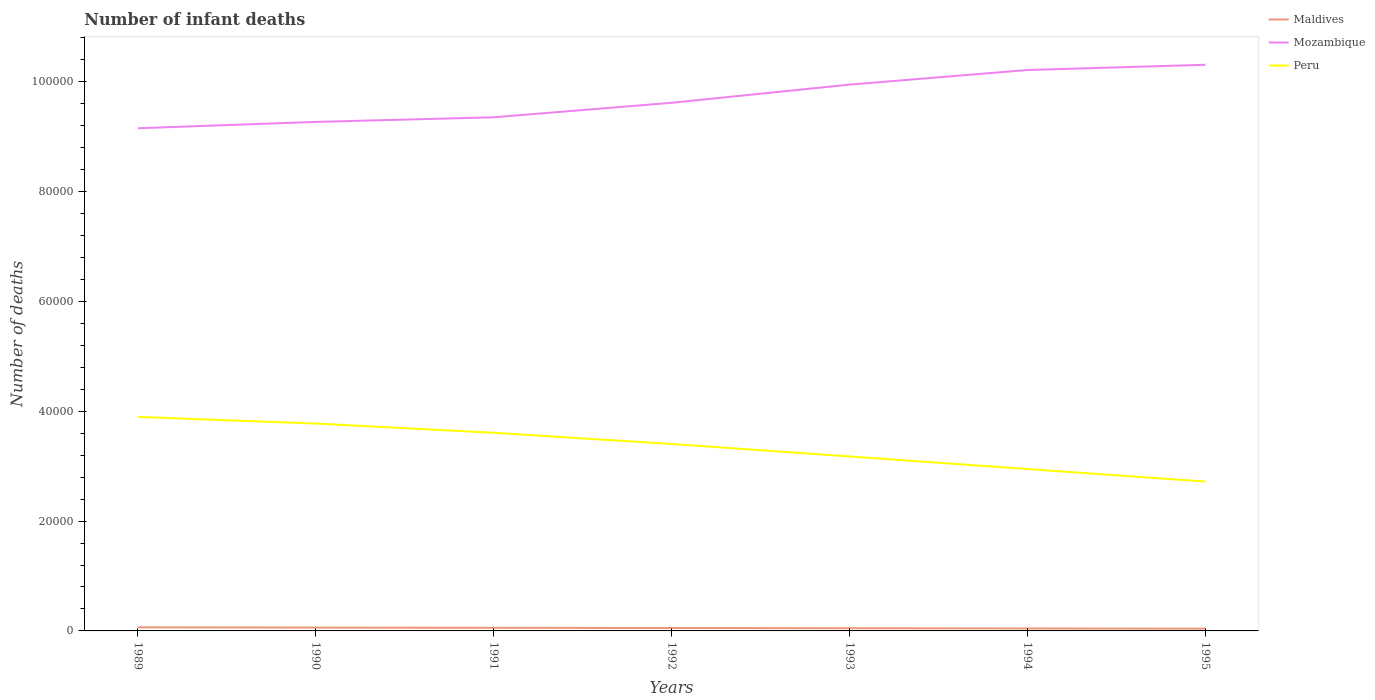Does the line corresponding to Mozambique intersect with the line corresponding to Peru?
Provide a short and direct response. No. Is the number of lines equal to the number of legend labels?
Offer a terse response. Yes. Across all years, what is the maximum number of infant deaths in Maldives?
Keep it short and to the point. 410. In which year was the number of infant deaths in Maldives maximum?
Keep it short and to the point. 1995. What is the total number of infant deaths in Mozambique in the graph?
Your answer should be compact. -3313. What is the difference between the highest and the second highest number of infant deaths in Peru?
Keep it short and to the point. 1.18e+04. What is the difference between the highest and the lowest number of infant deaths in Maldives?
Your answer should be compact. 4. Is the number of infant deaths in Mozambique strictly greater than the number of infant deaths in Peru over the years?
Your answer should be compact. No. How many years are there in the graph?
Provide a succinct answer. 7. Are the values on the major ticks of Y-axis written in scientific E-notation?
Your answer should be compact. No. What is the title of the graph?
Your answer should be very brief. Number of infant deaths. Does "Switzerland" appear as one of the legend labels in the graph?
Provide a short and direct response. No. What is the label or title of the X-axis?
Ensure brevity in your answer.  Years. What is the label or title of the Y-axis?
Offer a terse response. Number of deaths. What is the Number of deaths in Maldives in 1989?
Give a very brief answer. 653. What is the Number of deaths of Mozambique in 1989?
Give a very brief answer. 9.15e+04. What is the Number of deaths in Peru in 1989?
Offer a very short reply. 3.90e+04. What is the Number of deaths of Maldives in 1990?
Offer a terse response. 610. What is the Number of deaths in Mozambique in 1990?
Provide a succinct answer. 9.27e+04. What is the Number of deaths of Peru in 1990?
Provide a succinct answer. 3.78e+04. What is the Number of deaths in Maldives in 1991?
Keep it short and to the point. 570. What is the Number of deaths in Mozambique in 1991?
Your answer should be very brief. 9.35e+04. What is the Number of deaths in Peru in 1991?
Provide a succinct answer. 3.61e+04. What is the Number of deaths of Maldives in 1992?
Give a very brief answer. 531. What is the Number of deaths of Mozambique in 1992?
Make the answer very short. 9.62e+04. What is the Number of deaths in Peru in 1992?
Make the answer very short. 3.40e+04. What is the Number of deaths in Maldives in 1993?
Give a very brief answer. 491. What is the Number of deaths in Mozambique in 1993?
Your response must be concise. 9.95e+04. What is the Number of deaths of Peru in 1993?
Ensure brevity in your answer.  3.18e+04. What is the Number of deaths in Maldives in 1994?
Offer a very short reply. 450. What is the Number of deaths of Mozambique in 1994?
Make the answer very short. 1.02e+05. What is the Number of deaths in Peru in 1994?
Give a very brief answer. 2.95e+04. What is the Number of deaths in Maldives in 1995?
Give a very brief answer. 410. What is the Number of deaths in Mozambique in 1995?
Offer a terse response. 1.03e+05. What is the Number of deaths in Peru in 1995?
Keep it short and to the point. 2.72e+04. Across all years, what is the maximum Number of deaths of Maldives?
Your answer should be compact. 653. Across all years, what is the maximum Number of deaths in Mozambique?
Your answer should be very brief. 1.03e+05. Across all years, what is the maximum Number of deaths of Peru?
Provide a succinct answer. 3.90e+04. Across all years, what is the minimum Number of deaths of Maldives?
Provide a short and direct response. 410. Across all years, what is the minimum Number of deaths in Mozambique?
Offer a very short reply. 9.15e+04. Across all years, what is the minimum Number of deaths of Peru?
Your answer should be very brief. 2.72e+04. What is the total Number of deaths in Maldives in the graph?
Keep it short and to the point. 3715. What is the total Number of deaths in Mozambique in the graph?
Your response must be concise. 6.79e+05. What is the total Number of deaths in Peru in the graph?
Provide a short and direct response. 2.35e+05. What is the difference between the Number of deaths of Maldives in 1989 and that in 1990?
Offer a very short reply. 43. What is the difference between the Number of deaths of Mozambique in 1989 and that in 1990?
Give a very brief answer. -1155. What is the difference between the Number of deaths in Peru in 1989 and that in 1990?
Your answer should be very brief. 1211. What is the difference between the Number of deaths in Maldives in 1989 and that in 1991?
Offer a very short reply. 83. What is the difference between the Number of deaths of Mozambique in 1989 and that in 1991?
Keep it short and to the point. -1999. What is the difference between the Number of deaths of Peru in 1989 and that in 1991?
Keep it short and to the point. 2893. What is the difference between the Number of deaths in Maldives in 1989 and that in 1992?
Your answer should be compact. 122. What is the difference between the Number of deaths in Mozambique in 1989 and that in 1992?
Provide a short and direct response. -4634. What is the difference between the Number of deaths of Peru in 1989 and that in 1992?
Offer a terse response. 4930. What is the difference between the Number of deaths in Maldives in 1989 and that in 1993?
Provide a succinct answer. 162. What is the difference between the Number of deaths in Mozambique in 1989 and that in 1993?
Provide a short and direct response. -7947. What is the difference between the Number of deaths of Peru in 1989 and that in 1993?
Provide a succinct answer. 7202. What is the difference between the Number of deaths of Maldives in 1989 and that in 1994?
Your answer should be compact. 203. What is the difference between the Number of deaths of Mozambique in 1989 and that in 1994?
Ensure brevity in your answer.  -1.06e+04. What is the difference between the Number of deaths in Peru in 1989 and that in 1994?
Give a very brief answer. 9493. What is the difference between the Number of deaths of Maldives in 1989 and that in 1995?
Offer a very short reply. 243. What is the difference between the Number of deaths of Mozambique in 1989 and that in 1995?
Give a very brief answer. -1.16e+04. What is the difference between the Number of deaths of Peru in 1989 and that in 1995?
Give a very brief answer. 1.18e+04. What is the difference between the Number of deaths of Mozambique in 1990 and that in 1991?
Offer a very short reply. -844. What is the difference between the Number of deaths of Peru in 1990 and that in 1991?
Your answer should be compact. 1682. What is the difference between the Number of deaths of Maldives in 1990 and that in 1992?
Keep it short and to the point. 79. What is the difference between the Number of deaths of Mozambique in 1990 and that in 1992?
Provide a succinct answer. -3479. What is the difference between the Number of deaths in Peru in 1990 and that in 1992?
Offer a very short reply. 3719. What is the difference between the Number of deaths in Maldives in 1990 and that in 1993?
Provide a short and direct response. 119. What is the difference between the Number of deaths in Mozambique in 1990 and that in 1993?
Offer a terse response. -6792. What is the difference between the Number of deaths in Peru in 1990 and that in 1993?
Give a very brief answer. 5991. What is the difference between the Number of deaths in Maldives in 1990 and that in 1994?
Keep it short and to the point. 160. What is the difference between the Number of deaths in Mozambique in 1990 and that in 1994?
Ensure brevity in your answer.  -9450. What is the difference between the Number of deaths of Peru in 1990 and that in 1994?
Make the answer very short. 8282. What is the difference between the Number of deaths in Maldives in 1990 and that in 1995?
Offer a terse response. 200. What is the difference between the Number of deaths in Mozambique in 1990 and that in 1995?
Give a very brief answer. -1.04e+04. What is the difference between the Number of deaths of Peru in 1990 and that in 1995?
Offer a terse response. 1.06e+04. What is the difference between the Number of deaths in Maldives in 1991 and that in 1992?
Your answer should be compact. 39. What is the difference between the Number of deaths in Mozambique in 1991 and that in 1992?
Make the answer very short. -2635. What is the difference between the Number of deaths of Peru in 1991 and that in 1992?
Give a very brief answer. 2037. What is the difference between the Number of deaths of Maldives in 1991 and that in 1993?
Your answer should be compact. 79. What is the difference between the Number of deaths of Mozambique in 1991 and that in 1993?
Your answer should be compact. -5948. What is the difference between the Number of deaths of Peru in 1991 and that in 1993?
Your response must be concise. 4309. What is the difference between the Number of deaths of Maldives in 1991 and that in 1994?
Your answer should be very brief. 120. What is the difference between the Number of deaths of Mozambique in 1991 and that in 1994?
Make the answer very short. -8606. What is the difference between the Number of deaths in Peru in 1991 and that in 1994?
Provide a short and direct response. 6600. What is the difference between the Number of deaths of Maldives in 1991 and that in 1995?
Provide a short and direct response. 160. What is the difference between the Number of deaths in Mozambique in 1991 and that in 1995?
Give a very brief answer. -9562. What is the difference between the Number of deaths of Peru in 1991 and that in 1995?
Give a very brief answer. 8880. What is the difference between the Number of deaths in Maldives in 1992 and that in 1993?
Your answer should be compact. 40. What is the difference between the Number of deaths of Mozambique in 1992 and that in 1993?
Give a very brief answer. -3313. What is the difference between the Number of deaths in Peru in 1992 and that in 1993?
Provide a succinct answer. 2272. What is the difference between the Number of deaths in Mozambique in 1992 and that in 1994?
Provide a succinct answer. -5971. What is the difference between the Number of deaths in Peru in 1992 and that in 1994?
Provide a short and direct response. 4563. What is the difference between the Number of deaths of Maldives in 1992 and that in 1995?
Your answer should be very brief. 121. What is the difference between the Number of deaths of Mozambique in 1992 and that in 1995?
Offer a terse response. -6927. What is the difference between the Number of deaths in Peru in 1992 and that in 1995?
Provide a short and direct response. 6843. What is the difference between the Number of deaths of Maldives in 1993 and that in 1994?
Provide a short and direct response. 41. What is the difference between the Number of deaths of Mozambique in 1993 and that in 1994?
Make the answer very short. -2658. What is the difference between the Number of deaths in Peru in 1993 and that in 1994?
Give a very brief answer. 2291. What is the difference between the Number of deaths of Maldives in 1993 and that in 1995?
Keep it short and to the point. 81. What is the difference between the Number of deaths of Mozambique in 1993 and that in 1995?
Ensure brevity in your answer.  -3614. What is the difference between the Number of deaths of Peru in 1993 and that in 1995?
Provide a succinct answer. 4571. What is the difference between the Number of deaths in Maldives in 1994 and that in 1995?
Offer a very short reply. 40. What is the difference between the Number of deaths in Mozambique in 1994 and that in 1995?
Provide a succinct answer. -956. What is the difference between the Number of deaths of Peru in 1994 and that in 1995?
Your response must be concise. 2280. What is the difference between the Number of deaths in Maldives in 1989 and the Number of deaths in Mozambique in 1990?
Your answer should be very brief. -9.20e+04. What is the difference between the Number of deaths in Maldives in 1989 and the Number of deaths in Peru in 1990?
Provide a succinct answer. -3.71e+04. What is the difference between the Number of deaths in Mozambique in 1989 and the Number of deaths in Peru in 1990?
Provide a succinct answer. 5.38e+04. What is the difference between the Number of deaths in Maldives in 1989 and the Number of deaths in Mozambique in 1991?
Make the answer very short. -9.29e+04. What is the difference between the Number of deaths in Maldives in 1989 and the Number of deaths in Peru in 1991?
Provide a short and direct response. -3.54e+04. What is the difference between the Number of deaths in Mozambique in 1989 and the Number of deaths in Peru in 1991?
Ensure brevity in your answer.  5.55e+04. What is the difference between the Number of deaths of Maldives in 1989 and the Number of deaths of Mozambique in 1992?
Provide a short and direct response. -9.55e+04. What is the difference between the Number of deaths in Maldives in 1989 and the Number of deaths in Peru in 1992?
Your answer should be compact. -3.34e+04. What is the difference between the Number of deaths in Mozambique in 1989 and the Number of deaths in Peru in 1992?
Give a very brief answer. 5.75e+04. What is the difference between the Number of deaths of Maldives in 1989 and the Number of deaths of Mozambique in 1993?
Your answer should be very brief. -9.88e+04. What is the difference between the Number of deaths of Maldives in 1989 and the Number of deaths of Peru in 1993?
Your answer should be very brief. -3.11e+04. What is the difference between the Number of deaths in Mozambique in 1989 and the Number of deaths in Peru in 1993?
Provide a succinct answer. 5.98e+04. What is the difference between the Number of deaths of Maldives in 1989 and the Number of deaths of Mozambique in 1994?
Keep it short and to the point. -1.01e+05. What is the difference between the Number of deaths of Maldives in 1989 and the Number of deaths of Peru in 1994?
Offer a very short reply. -2.88e+04. What is the difference between the Number of deaths of Mozambique in 1989 and the Number of deaths of Peru in 1994?
Your answer should be compact. 6.21e+04. What is the difference between the Number of deaths of Maldives in 1989 and the Number of deaths of Mozambique in 1995?
Provide a succinct answer. -1.02e+05. What is the difference between the Number of deaths of Maldives in 1989 and the Number of deaths of Peru in 1995?
Offer a terse response. -2.65e+04. What is the difference between the Number of deaths of Mozambique in 1989 and the Number of deaths of Peru in 1995?
Keep it short and to the point. 6.43e+04. What is the difference between the Number of deaths of Maldives in 1990 and the Number of deaths of Mozambique in 1991?
Make the answer very short. -9.29e+04. What is the difference between the Number of deaths of Maldives in 1990 and the Number of deaths of Peru in 1991?
Make the answer very short. -3.55e+04. What is the difference between the Number of deaths of Mozambique in 1990 and the Number of deaths of Peru in 1991?
Offer a terse response. 5.66e+04. What is the difference between the Number of deaths of Maldives in 1990 and the Number of deaths of Mozambique in 1992?
Your answer should be compact. -9.56e+04. What is the difference between the Number of deaths of Maldives in 1990 and the Number of deaths of Peru in 1992?
Offer a terse response. -3.34e+04. What is the difference between the Number of deaths in Mozambique in 1990 and the Number of deaths in Peru in 1992?
Give a very brief answer. 5.87e+04. What is the difference between the Number of deaths of Maldives in 1990 and the Number of deaths of Mozambique in 1993?
Give a very brief answer. -9.89e+04. What is the difference between the Number of deaths in Maldives in 1990 and the Number of deaths in Peru in 1993?
Your answer should be very brief. -3.12e+04. What is the difference between the Number of deaths of Mozambique in 1990 and the Number of deaths of Peru in 1993?
Your answer should be very brief. 6.09e+04. What is the difference between the Number of deaths in Maldives in 1990 and the Number of deaths in Mozambique in 1994?
Ensure brevity in your answer.  -1.02e+05. What is the difference between the Number of deaths in Maldives in 1990 and the Number of deaths in Peru in 1994?
Provide a succinct answer. -2.89e+04. What is the difference between the Number of deaths of Mozambique in 1990 and the Number of deaths of Peru in 1994?
Keep it short and to the point. 6.32e+04. What is the difference between the Number of deaths of Maldives in 1990 and the Number of deaths of Mozambique in 1995?
Ensure brevity in your answer.  -1.02e+05. What is the difference between the Number of deaths of Maldives in 1990 and the Number of deaths of Peru in 1995?
Provide a short and direct response. -2.66e+04. What is the difference between the Number of deaths of Mozambique in 1990 and the Number of deaths of Peru in 1995?
Give a very brief answer. 6.55e+04. What is the difference between the Number of deaths of Maldives in 1991 and the Number of deaths of Mozambique in 1992?
Your answer should be compact. -9.56e+04. What is the difference between the Number of deaths in Maldives in 1991 and the Number of deaths in Peru in 1992?
Offer a terse response. -3.35e+04. What is the difference between the Number of deaths in Mozambique in 1991 and the Number of deaths in Peru in 1992?
Give a very brief answer. 5.95e+04. What is the difference between the Number of deaths in Maldives in 1991 and the Number of deaths in Mozambique in 1993?
Ensure brevity in your answer.  -9.89e+04. What is the difference between the Number of deaths of Maldives in 1991 and the Number of deaths of Peru in 1993?
Provide a short and direct response. -3.12e+04. What is the difference between the Number of deaths in Mozambique in 1991 and the Number of deaths in Peru in 1993?
Your answer should be compact. 6.18e+04. What is the difference between the Number of deaths of Maldives in 1991 and the Number of deaths of Mozambique in 1994?
Your response must be concise. -1.02e+05. What is the difference between the Number of deaths in Maldives in 1991 and the Number of deaths in Peru in 1994?
Give a very brief answer. -2.89e+04. What is the difference between the Number of deaths in Mozambique in 1991 and the Number of deaths in Peru in 1994?
Offer a terse response. 6.41e+04. What is the difference between the Number of deaths in Maldives in 1991 and the Number of deaths in Mozambique in 1995?
Your answer should be very brief. -1.03e+05. What is the difference between the Number of deaths in Maldives in 1991 and the Number of deaths in Peru in 1995?
Give a very brief answer. -2.66e+04. What is the difference between the Number of deaths in Mozambique in 1991 and the Number of deaths in Peru in 1995?
Provide a short and direct response. 6.63e+04. What is the difference between the Number of deaths in Maldives in 1992 and the Number of deaths in Mozambique in 1993?
Give a very brief answer. -9.90e+04. What is the difference between the Number of deaths in Maldives in 1992 and the Number of deaths in Peru in 1993?
Provide a succinct answer. -3.12e+04. What is the difference between the Number of deaths of Mozambique in 1992 and the Number of deaths of Peru in 1993?
Provide a succinct answer. 6.44e+04. What is the difference between the Number of deaths of Maldives in 1992 and the Number of deaths of Mozambique in 1994?
Offer a very short reply. -1.02e+05. What is the difference between the Number of deaths of Maldives in 1992 and the Number of deaths of Peru in 1994?
Make the answer very short. -2.90e+04. What is the difference between the Number of deaths of Mozambique in 1992 and the Number of deaths of Peru in 1994?
Keep it short and to the point. 6.67e+04. What is the difference between the Number of deaths of Maldives in 1992 and the Number of deaths of Mozambique in 1995?
Offer a very short reply. -1.03e+05. What is the difference between the Number of deaths of Maldives in 1992 and the Number of deaths of Peru in 1995?
Make the answer very short. -2.67e+04. What is the difference between the Number of deaths in Mozambique in 1992 and the Number of deaths in Peru in 1995?
Offer a terse response. 6.90e+04. What is the difference between the Number of deaths in Maldives in 1993 and the Number of deaths in Mozambique in 1994?
Ensure brevity in your answer.  -1.02e+05. What is the difference between the Number of deaths in Maldives in 1993 and the Number of deaths in Peru in 1994?
Make the answer very short. -2.90e+04. What is the difference between the Number of deaths in Mozambique in 1993 and the Number of deaths in Peru in 1994?
Ensure brevity in your answer.  7.00e+04. What is the difference between the Number of deaths of Maldives in 1993 and the Number of deaths of Mozambique in 1995?
Provide a short and direct response. -1.03e+05. What is the difference between the Number of deaths in Maldives in 1993 and the Number of deaths in Peru in 1995?
Provide a succinct answer. -2.67e+04. What is the difference between the Number of deaths of Mozambique in 1993 and the Number of deaths of Peru in 1995?
Make the answer very short. 7.23e+04. What is the difference between the Number of deaths in Maldives in 1994 and the Number of deaths in Mozambique in 1995?
Keep it short and to the point. -1.03e+05. What is the difference between the Number of deaths in Maldives in 1994 and the Number of deaths in Peru in 1995?
Your response must be concise. -2.68e+04. What is the difference between the Number of deaths in Mozambique in 1994 and the Number of deaths in Peru in 1995?
Make the answer very short. 7.49e+04. What is the average Number of deaths in Maldives per year?
Give a very brief answer. 530.71. What is the average Number of deaths of Mozambique per year?
Provide a succinct answer. 9.70e+04. What is the average Number of deaths of Peru per year?
Your answer should be compact. 3.36e+04. In the year 1989, what is the difference between the Number of deaths in Maldives and Number of deaths in Mozambique?
Your answer should be compact. -9.09e+04. In the year 1989, what is the difference between the Number of deaths in Maldives and Number of deaths in Peru?
Keep it short and to the point. -3.83e+04. In the year 1989, what is the difference between the Number of deaths of Mozambique and Number of deaths of Peru?
Offer a terse response. 5.26e+04. In the year 1990, what is the difference between the Number of deaths in Maldives and Number of deaths in Mozambique?
Provide a short and direct response. -9.21e+04. In the year 1990, what is the difference between the Number of deaths in Maldives and Number of deaths in Peru?
Your answer should be compact. -3.72e+04. In the year 1990, what is the difference between the Number of deaths in Mozambique and Number of deaths in Peru?
Make the answer very short. 5.49e+04. In the year 1991, what is the difference between the Number of deaths of Maldives and Number of deaths of Mozambique?
Make the answer very short. -9.30e+04. In the year 1991, what is the difference between the Number of deaths of Maldives and Number of deaths of Peru?
Your answer should be very brief. -3.55e+04. In the year 1991, what is the difference between the Number of deaths of Mozambique and Number of deaths of Peru?
Your response must be concise. 5.75e+04. In the year 1992, what is the difference between the Number of deaths in Maldives and Number of deaths in Mozambique?
Offer a terse response. -9.56e+04. In the year 1992, what is the difference between the Number of deaths of Maldives and Number of deaths of Peru?
Your answer should be compact. -3.35e+04. In the year 1992, what is the difference between the Number of deaths in Mozambique and Number of deaths in Peru?
Give a very brief answer. 6.21e+04. In the year 1993, what is the difference between the Number of deaths of Maldives and Number of deaths of Mozambique?
Provide a succinct answer. -9.90e+04. In the year 1993, what is the difference between the Number of deaths in Maldives and Number of deaths in Peru?
Keep it short and to the point. -3.13e+04. In the year 1993, what is the difference between the Number of deaths in Mozambique and Number of deaths in Peru?
Make the answer very short. 6.77e+04. In the year 1994, what is the difference between the Number of deaths of Maldives and Number of deaths of Mozambique?
Offer a very short reply. -1.02e+05. In the year 1994, what is the difference between the Number of deaths of Maldives and Number of deaths of Peru?
Provide a short and direct response. -2.90e+04. In the year 1994, what is the difference between the Number of deaths in Mozambique and Number of deaths in Peru?
Your response must be concise. 7.27e+04. In the year 1995, what is the difference between the Number of deaths of Maldives and Number of deaths of Mozambique?
Keep it short and to the point. -1.03e+05. In the year 1995, what is the difference between the Number of deaths in Maldives and Number of deaths in Peru?
Your response must be concise. -2.68e+04. In the year 1995, what is the difference between the Number of deaths in Mozambique and Number of deaths in Peru?
Provide a short and direct response. 7.59e+04. What is the ratio of the Number of deaths in Maldives in 1989 to that in 1990?
Keep it short and to the point. 1.07. What is the ratio of the Number of deaths in Mozambique in 1989 to that in 1990?
Ensure brevity in your answer.  0.99. What is the ratio of the Number of deaths in Peru in 1989 to that in 1990?
Your response must be concise. 1.03. What is the ratio of the Number of deaths of Maldives in 1989 to that in 1991?
Give a very brief answer. 1.15. What is the ratio of the Number of deaths in Mozambique in 1989 to that in 1991?
Offer a terse response. 0.98. What is the ratio of the Number of deaths in Peru in 1989 to that in 1991?
Offer a terse response. 1.08. What is the ratio of the Number of deaths of Maldives in 1989 to that in 1992?
Your response must be concise. 1.23. What is the ratio of the Number of deaths of Mozambique in 1989 to that in 1992?
Provide a short and direct response. 0.95. What is the ratio of the Number of deaths of Peru in 1989 to that in 1992?
Provide a succinct answer. 1.14. What is the ratio of the Number of deaths of Maldives in 1989 to that in 1993?
Offer a very short reply. 1.33. What is the ratio of the Number of deaths in Mozambique in 1989 to that in 1993?
Keep it short and to the point. 0.92. What is the ratio of the Number of deaths in Peru in 1989 to that in 1993?
Your answer should be compact. 1.23. What is the ratio of the Number of deaths of Maldives in 1989 to that in 1994?
Provide a short and direct response. 1.45. What is the ratio of the Number of deaths of Mozambique in 1989 to that in 1994?
Your answer should be compact. 0.9. What is the ratio of the Number of deaths in Peru in 1989 to that in 1994?
Ensure brevity in your answer.  1.32. What is the ratio of the Number of deaths in Maldives in 1989 to that in 1995?
Offer a terse response. 1.59. What is the ratio of the Number of deaths in Mozambique in 1989 to that in 1995?
Provide a succinct answer. 0.89. What is the ratio of the Number of deaths of Peru in 1989 to that in 1995?
Give a very brief answer. 1.43. What is the ratio of the Number of deaths in Maldives in 1990 to that in 1991?
Offer a terse response. 1.07. What is the ratio of the Number of deaths of Peru in 1990 to that in 1991?
Your answer should be very brief. 1.05. What is the ratio of the Number of deaths of Maldives in 1990 to that in 1992?
Offer a very short reply. 1.15. What is the ratio of the Number of deaths in Mozambique in 1990 to that in 1992?
Keep it short and to the point. 0.96. What is the ratio of the Number of deaths of Peru in 1990 to that in 1992?
Provide a short and direct response. 1.11. What is the ratio of the Number of deaths in Maldives in 1990 to that in 1993?
Offer a very short reply. 1.24. What is the ratio of the Number of deaths in Mozambique in 1990 to that in 1993?
Make the answer very short. 0.93. What is the ratio of the Number of deaths of Peru in 1990 to that in 1993?
Provide a succinct answer. 1.19. What is the ratio of the Number of deaths in Maldives in 1990 to that in 1994?
Your answer should be very brief. 1.36. What is the ratio of the Number of deaths in Mozambique in 1990 to that in 1994?
Ensure brevity in your answer.  0.91. What is the ratio of the Number of deaths of Peru in 1990 to that in 1994?
Provide a short and direct response. 1.28. What is the ratio of the Number of deaths of Maldives in 1990 to that in 1995?
Your answer should be very brief. 1.49. What is the ratio of the Number of deaths of Mozambique in 1990 to that in 1995?
Your answer should be compact. 0.9. What is the ratio of the Number of deaths in Peru in 1990 to that in 1995?
Provide a succinct answer. 1.39. What is the ratio of the Number of deaths in Maldives in 1991 to that in 1992?
Offer a terse response. 1.07. What is the ratio of the Number of deaths in Mozambique in 1991 to that in 1992?
Keep it short and to the point. 0.97. What is the ratio of the Number of deaths in Peru in 1991 to that in 1992?
Ensure brevity in your answer.  1.06. What is the ratio of the Number of deaths in Maldives in 1991 to that in 1993?
Ensure brevity in your answer.  1.16. What is the ratio of the Number of deaths in Mozambique in 1991 to that in 1993?
Your response must be concise. 0.94. What is the ratio of the Number of deaths of Peru in 1991 to that in 1993?
Provide a succinct answer. 1.14. What is the ratio of the Number of deaths of Maldives in 1991 to that in 1994?
Offer a very short reply. 1.27. What is the ratio of the Number of deaths in Mozambique in 1991 to that in 1994?
Your answer should be very brief. 0.92. What is the ratio of the Number of deaths of Peru in 1991 to that in 1994?
Give a very brief answer. 1.22. What is the ratio of the Number of deaths of Maldives in 1991 to that in 1995?
Keep it short and to the point. 1.39. What is the ratio of the Number of deaths of Mozambique in 1991 to that in 1995?
Provide a short and direct response. 0.91. What is the ratio of the Number of deaths in Peru in 1991 to that in 1995?
Your answer should be very brief. 1.33. What is the ratio of the Number of deaths of Maldives in 1992 to that in 1993?
Offer a very short reply. 1.08. What is the ratio of the Number of deaths of Mozambique in 1992 to that in 1993?
Ensure brevity in your answer.  0.97. What is the ratio of the Number of deaths in Peru in 1992 to that in 1993?
Keep it short and to the point. 1.07. What is the ratio of the Number of deaths in Maldives in 1992 to that in 1994?
Provide a short and direct response. 1.18. What is the ratio of the Number of deaths of Mozambique in 1992 to that in 1994?
Your response must be concise. 0.94. What is the ratio of the Number of deaths of Peru in 1992 to that in 1994?
Offer a terse response. 1.15. What is the ratio of the Number of deaths of Maldives in 1992 to that in 1995?
Provide a short and direct response. 1.3. What is the ratio of the Number of deaths in Mozambique in 1992 to that in 1995?
Offer a very short reply. 0.93. What is the ratio of the Number of deaths in Peru in 1992 to that in 1995?
Your response must be concise. 1.25. What is the ratio of the Number of deaths in Maldives in 1993 to that in 1994?
Offer a terse response. 1.09. What is the ratio of the Number of deaths of Peru in 1993 to that in 1994?
Provide a short and direct response. 1.08. What is the ratio of the Number of deaths in Maldives in 1993 to that in 1995?
Ensure brevity in your answer.  1.2. What is the ratio of the Number of deaths in Mozambique in 1993 to that in 1995?
Offer a very short reply. 0.96. What is the ratio of the Number of deaths in Peru in 1993 to that in 1995?
Your response must be concise. 1.17. What is the ratio of the Number of deaths in Maldives in 1994 to that in 1995?
Your response must be concise. 1.1. What is the ratio of the Number of deaths in Mozambique in 1994 to that in 1995?
Provide a succinct answer. 0.99. What is the ratio of the Number of deaths of Peru in 1994 to that in 1995?
Make the answer very short. 1.08. What is the difference between the highest and the second highest Number of deaths of Mozambique?
Offer a very short reply. 956. What is the difference between the highest and the second highest Number of deaths of Peru?
Make the answer very short. 1211. What is the difference between the highest and the lowest Number of deaths in Maldives?
Offer a very short reply. 243. What is the difference between the highest and the lowest Number of deaths in Mozambique?
Give a very brief answer. 1.16e+04. What is the difference between the highest and the lowest Number of deaths in Peru?
Give a very brief answer. 1.18e+04. 